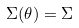<formula> <loc_0><loc_0><loc_500><loc_500>\Sigma ( \theta ) = \Sigma</formula> 